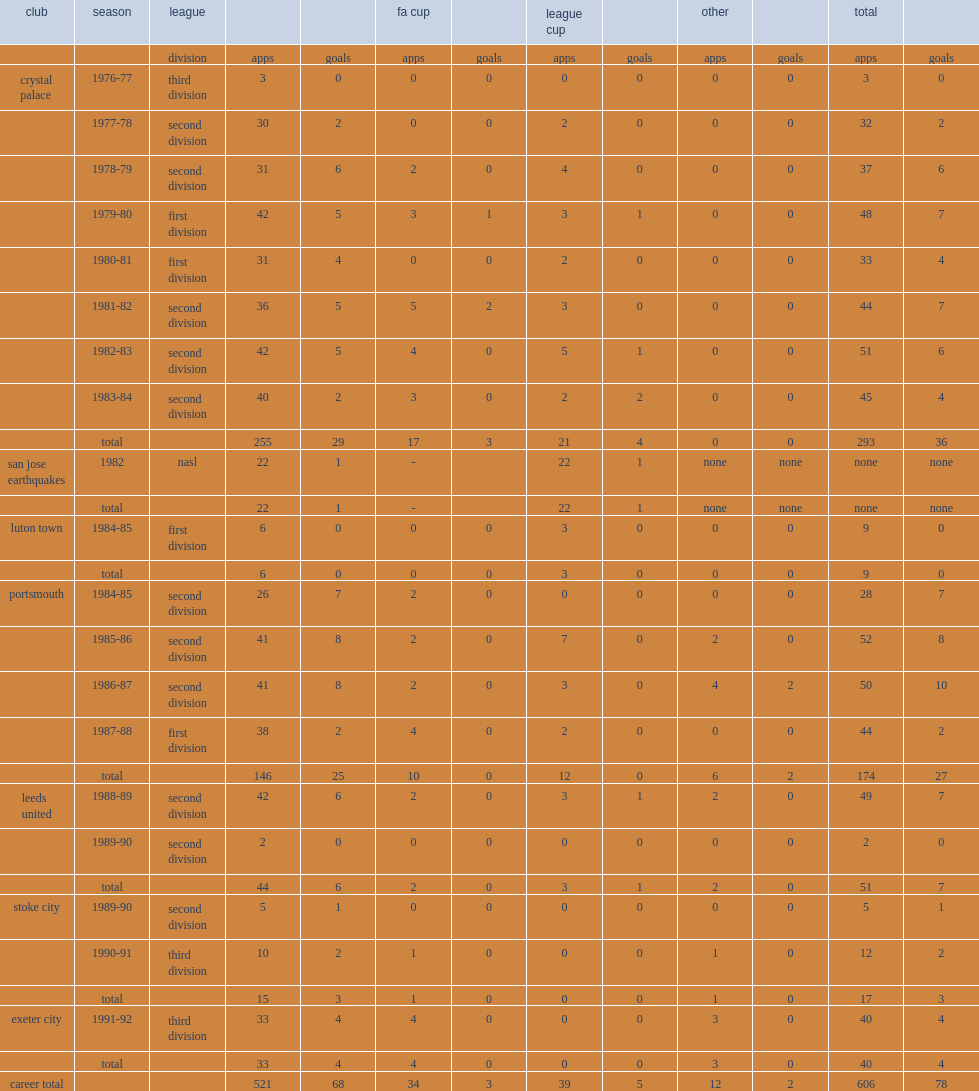Could you help me parse every detail presented in this table? {'header': ['club', 'season', 'league', '', '', 'fa cup', '', 'league cup', '', 'other', '', 'total', ''], 'rows': [['', '', 'division', 'apps', 'goals', 'apps', 'goals', 'apps', 'goals', 'apps', 'goals', 'apps', 'goals'], ['crystal palace', '1976-77', 'third division', '3', '0', '0', '0', '0', '0', '0', '0', '3', '0'], ['', '1977-78', 'second division', '30', '2', '0', '0', '2', '0', '0', '0', '32', '2'], ['', '1978-79', 'second division', '31', '6', '2', '0', '4', '0', '0', '0', '37', '6'], ['', '1979-80', 'first division', '42', '5', '3', '1', '3', '1', '0', '0', '48', '7'], ['', '1980-81', 'first division', '31', '4', '0', '0', '2', '0', '0', '0', '33', '4'], ['', '1981-82', 'second division', '36', '5', '5', '2', '3', '0', '0', '0', '44', '7'], ['', '1982-83', 'second division', '42', '5', '4', '0', '5', '1', '0', '0', '51', '6'], ['', '1983-84', 'second division', '40', '2', '3', '0', '2', '2', '0', '0', '45', '4'], ['', 'total', '', '255', '29', '17', '3', '21', '4', '0', '0', '293', '36'], ['san jose earthquakes', '1982', 'nasl', '22', '1', '-', '', '22', '1', 'none', 'none', 'none', 'none'], ['', 'total', '', '22', '1', '-', '', '22', '1', 'none', 'none', 'none', 'none'], ['luton town', '1984-85', 'first division', '6', '0', '0', '0', '3', '0', '0', '0', '9', '0'], ['', 'total', '', '6', '0', '0', '0', '3', '0', '0', '0', '9', '0'], ['portsmouth', '1984-85', 'second division', '26', '7', '2', '0', '0', '0', '0', '0', '28', '7'], ['', '1985-86', 'second division', '41', '8', '2', '0', '7', '0', '2', '0', '52', '8'], ['', '1986-87', 'second division', '41', '8', '2', '0', '3', '0', '4', '2', '50', '10'], ['', '1987-88', 'first division', '38', '2', '4', '0', '2', '0', '0', '0', '44', '2'], ['', 'total', '', '146', '25', '10', '0', '12', '0', '6', '2', '174', '27'], ['leeds united', '1988-89', 'second division', '42', '6', '2', '0', '3', '1', '2', '0', '49', '7'], ['', '1989-90', 'second division', '2', '0', '0', '0', '0', '0', '0', '0', '2', '0'], ['', 'total', '', '44', '6', '2', '0', '3', '1', '2', '0', '51', '7'], ['stoke city', '1989-90', 'second division', '5', '1', '0', '0', '0', '0', '0', '0', '5', '1'], ['', '1990-91', 'third division', '10', '2', '1', '0', '0', '0', '1', '0', '12', '2'], ['', 'total', '', '15', '3', '1', '0', '0', '0', '1', '0', '17', '3'], ['exeter city', '1991-92', 'third division', '33', '4', '4', '0', '0', '0', '3', '0', '40', '4'], ['', 'total', '', '33', '4', '4', '0', '0', '0', '3', '0', '40', '4'], ['career total', '', '', '521', '68', '34', '3', '39', '5', '12', '2', '606', '78']]} Which club did vince hilaire join and make 255 league appearances, scoring 29 goals. Crystal palace. 